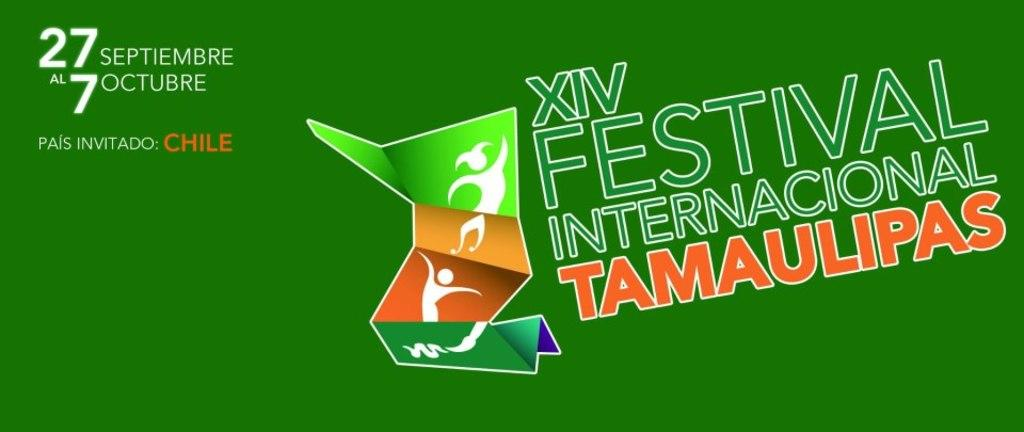<image>
Share a concise interpretation of the image provided. A green sign advertising  the festival internacional tamaulipas. 